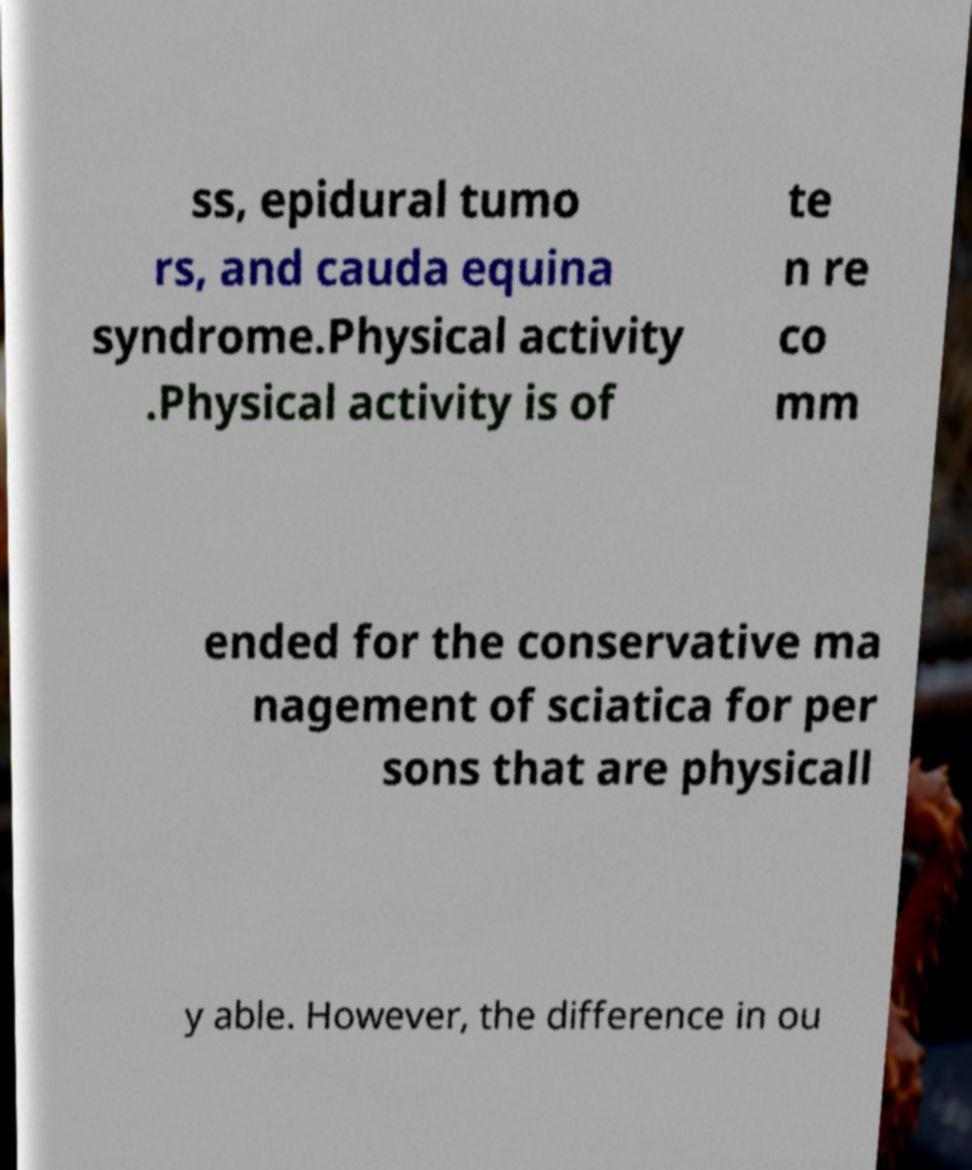Could you extract and type out the text from this image? ss, epidural tumo rs, and cauda equina syndrome.Physical activity .Physical activity is of te n re co mm ended for the conservative ma nagement of sciatica for per sons that are physicall y able. However, the difference in ou 